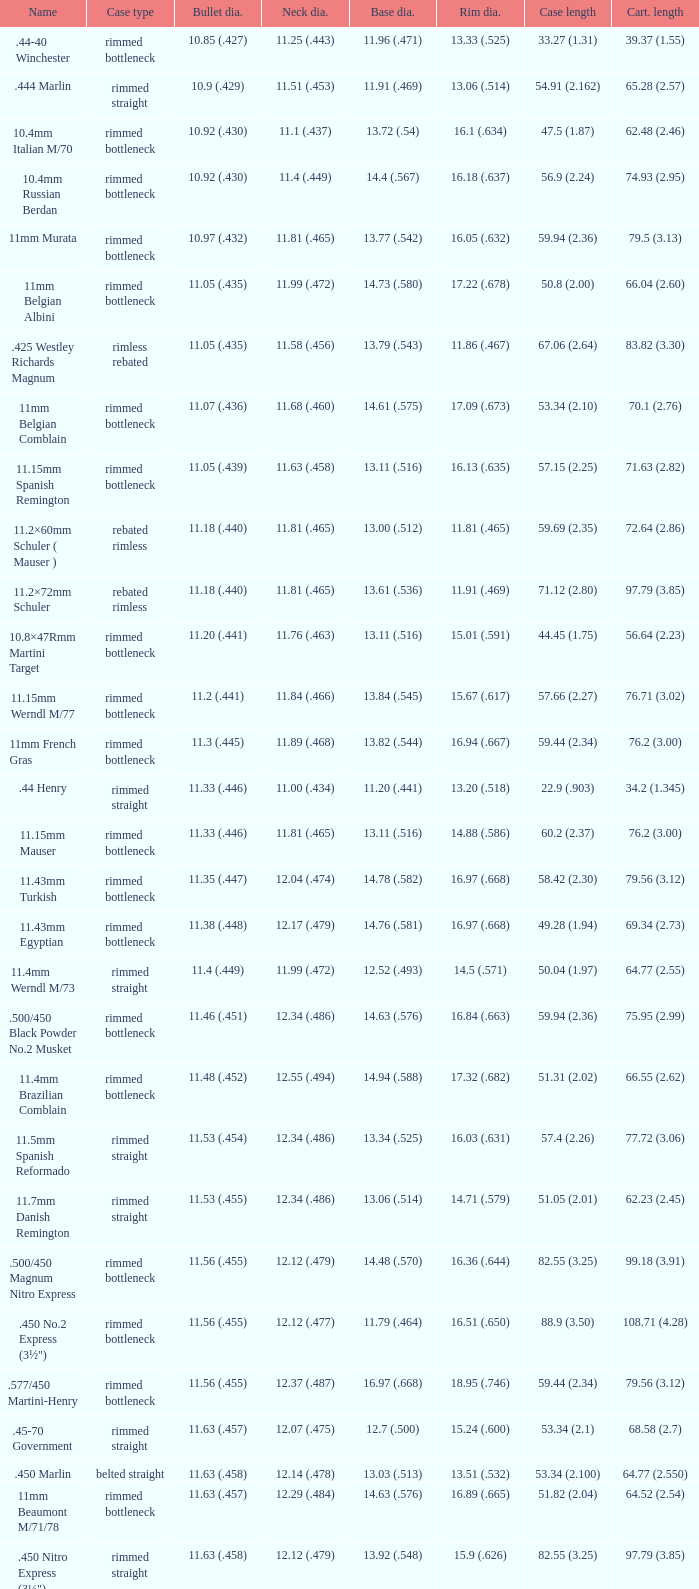Which Bullet diameter has a Neck diameter of 12.17 (.479)? 11.38 (.448). 